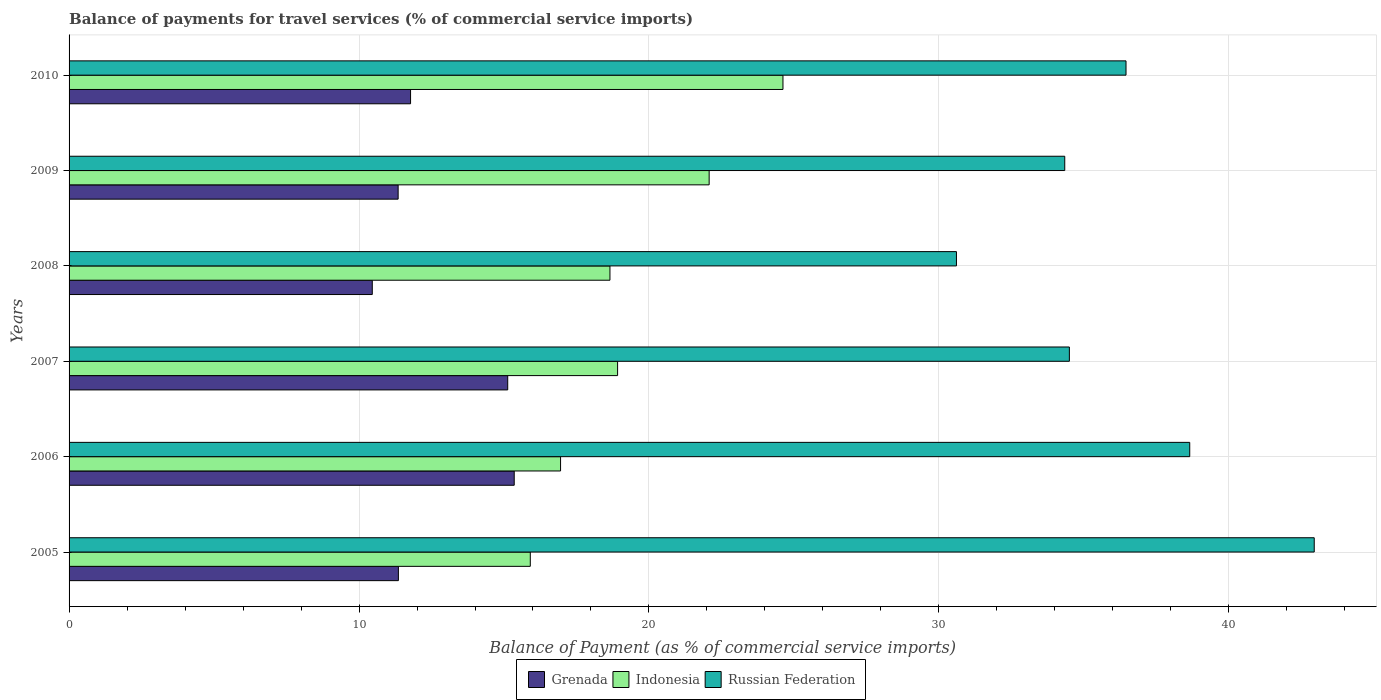How many bars are there on the 2nd tick from the top?
Provide a short and direct response. 3. How many bars are there on the 2nd tick from the bottom?
Keep it short and to the point. 3. What is the label of the 4th group of bars from the top?
Keep it short and to the point. 2007. What is the balance of payments for travel services in Indonesia in 2006?
Your answer should be compact. 16.95. Across all years, what is the maximum balance of payments for travel services in Indonesia?
Keep it short and to the point. 24.62. Across all years, what is the minimum balance of payments for travel services in Grenada?
Offer a terse response. 10.46. In which year was the balance of payments for travel services in Grenada maximum?
Provide a succinct answer. 2006. In which year was the balance of payments for travel services in Russian Federation minimum?
Your response must be concise. 2008. What is the total balance of payments for travel services in Grenada in the graph?
Provide a short and direct response. 75.42. What is the difference between the balance of payments for travel services in Indonesia in 2005 and that in 2006?
Offer a very short reply. -1.04. What is the difference between the balance of payments for travel services in Grenada in 2010 and the balance of payments for travel services in Indonesia in 2009?
Provide a short and direct response. -10.3. What is the average balance of payments for travel services in Indonesia per year?
Offer a terse response. 19.52. In the year 2008, what is the difference between the balance of payments for travel services in Indonesia and balance of payments for travel services in Russian Federation?
Provide a succinct answer. -11.95. In how many years, is the balance of payments for travel services in Russian Federation greater than 26 %?
Give a very brief answer. 6. What is the ratio of the balance of payments for travel services in Russian Federation in 2007 to that in 2010?
Keep it short and to the point. 0.95. Is the balance of payments for travel services in Indonesia in 2006 less than that in 2007?
Offer a terse response. Yes. What is the difference between the highest and the second highest balance of payments for travel services in Grenada?
Offer a very short reply. 0.22. What is the difference between the highest and the lowest balance of payments for travel services in Grenada?
Keep it short and to the point. 4.9. In how many years, is the balance of payments for travel services in Russian Federation greater than the average balance of payments for travel services in Russian Federation taken over all years?
Give a very brief answer. 3. What does the 2nd bar from the top in 2009 represents?
Give a very brief answer. Indonesia. What does the 2nd bar from the bottom in 2007 represents?
Provide a succinct answer. Indonesia. Is it the case that in every year, the sum of the balance of payments for travel services in Grenada and balance of payments for travel services in Russian Federation is greater than the balance of payments for travel services in Indonesia?
Your answer should be compact. Yes. Are all the bars in the graph horizontal?
Your answer should be compact. Yes. What is the difference between two consecutive major ticks on the X-axis?
Offer a very short reply. 10. Are the values on the major ticks of X-axis written in scientific E-notation?
Give a very brief answer. No. Where does the legend appear in the graph?
Provide a succinct answer. Bottom center. How many legend labels are there?
Provide a short and direct response. 3. How are the legend labels stacked?
Keep it short and to the point. Horizontal. What is the title of the graph?
Ensure brevity in your answer.  Balance of payments for travel services (% of commercial service imports). What is the label or title of the X-axis?
Your response must be concise. Balance of Payment (as % of commercial service imports). What is the Balance of Payment (as % of commercial service imports) of Grenada in 2005?
Make the answer very short. 11.36. What is the Balance of Payment (as % of commercial service imports) in Indonesia in 2005?
Provide a short and direct response. 15.91. What is the Balance of Payment (as % of commercial service imports) in Russian Federation in 2005?
Ensure brevity in your answer.  42.94. What is the Balance of Payment (as % of commercial service imports) of Grenada in 2006?
Provide a short and direct response. 15.35. What is the Balance of Payment (as % of commercial service imports) of Indonesia in 2006?
Your response must be concise. 16.95. What is the Balance of Payment (as % of commercial service imports) in Russian Federation in 2006?
Your response must be concise. 38.65. What is the Balance of Payment (as % of commercial service imports) in Grenada in 2007?
Give a very brief answer. 15.13. What is the Balance of Payment (as % of commercial service imports) in Indonesia in 2007?
Offer a terse response. 18.92. What is the Balance of Payment (as % of commercial service imports) of Russian Federation in 2007?
Provide a succinct answer. 34.5. What is the Balance of Payment (as % of commercial service imports) of Grenada in 2008?
Give a very brief answer. 10.46. What is the Balance of Payment (as % of commercial service imports) of Indonesia in 2008?
Offer a very short reply. 18.65. What is the Balance of Payment (as % of commercial service imports) in Russian Federation in 2008?
Your answer should be very brief. 30.6. What is the Balance of Payment (as % of commercial service imports) of Grenada in 2009?
Offer a very short reply. 11.35. What is the Balance of Payment (as % of commercial service imports) in Indonesia in 2009?
Offer a terse response. 22.08. What is the Balance of Payment (as % of commercial service imports) in Russian Federation in 2009?
Offer a very short reply. 34.34. What is the Balance of Payment (as % of commercial service imports) in Grenada in 2010?
Make the answer very short. 11.78. What is the Balance of Payment (as % of commercial service imports) in Indonesia in 2010?
Your response must be concise. 24.62. What is the Balance of Payment (as % of commercial service imports) in Russian Federation in 2010?
Keep it short and to the point. 36.45. Across all years, what is the maximum Balance of Payment (as % of commercial service imports) of Grenada?
Provide a succinct answer. 15.35. Across all years, what is the maximum Balance of Payment (as % of commercial service imports) of Indonesia?
Make the answer very short. 24.62. Across all years, what is the maximum Balance of Payment (as % of commercial service imports) in Russian Federation?
Your answer should be very brief. 42.94. Across all years, what is the minimum Balance of Payment (as % of commercial service imports) in Grenada?
Keep it short and to the point. 10.46. Across all years, what is the minimum Balance of Payment (as % of commercial service imports) of Indonesia?
Make the answer very short. 15.91. Across all years, what is the minimum Balance of Payment (as % of commercial service imports) of Russian Federation?
Keep it short and to the point. 30.6. What is the total Balance of Payment (as % of commercial service imports) in Grenada in the graph?
Your answer should be compact. 75.42. What is the total Balance of Payment (as % of commercial service imports) of Indonesia in the graph?
Give a very brief answer. 117.13. What is the total Balance of Payment (as % of commercial service imports) in Russian Federation in the graph?
Offer a very short reply. 217.49. What is the difference between the Balance of Payment (as % of commercial service imports) in Grenada in 2005 and that in 2006?
Provide a succinct answer. -3.99. What is the difference between the Balance of Payment (as % of commercial service imports) in Indonesia in 2005 and that in 2006?
Provide a short and direct response. -1.04. What is the difference between the Balance of Payment (as % of commercial service imports) of Russian Federation in 2005 and that in 2006?
Offer a very short reply. 4.29. What is the difference between the Balance of Payment (as % of commercial service imports) of Grenada in 2005 and that in 2007?
Make the answer very short. -3.77. What is the difference between the Balance of Payment (as % of commercial service imports) in Indonesia in 2005 and that in 2007?
Make the answer very short. -3.01. What is the difference between the Balance of Payment (as % of commercial service imports) of Russian Federation in 2005 and that in 2007?
Provide a succinct answer. 8.44. What is the difference between the Balance of Payment (as % of commercial service imports) in Grenada in 2005 and that in 2008?
Provide a succinct answer. 0.9. What is the difference between the Balance of Payment (as % of commercial service imports) in Indonesia in 2005 and that in 2008?
Your response must be concise. -2.75. What is the difference between the Balance of Payment (as % of commercial service imports) in Russian Federation in 2005 and that in 2008?
Your answer should be very brief. 12.34. What is the difference between the Balance of Payment (as % of commercial service imports) of Grenada in 2005 and that in 2009?
Keep it short and to the point. 0.01. What is the difference between the Balance of Payment (as % of commercial service imports) of Indonesia in 2005 and that in 2009?
Offer a terse response. -6.17. What is the difference between the Balance of Payment (as % of commercial service imports) in Russian Federation in 2005 and that in 2009?
Provide a succinct answer. 8.6. What is the difference between the Balance of Payment (as % of commercial service imports) of Grenada in 2005 and that in 2010?
Your answer should be compact. -0.42. What is the difference between the Balance of Payment (as % of commercial service imports) in Indonesia in 2005 and that in 2010?
Keep it short and to the point. -8.71. What is the difference between the Balance of Payment (as % of commercial service imports) in Russian Federation in 2005 and that in 2010?
Give a very brief answer. 6.49. What is the difference between the Balance of Payment (as % of commercial service imports) of Grenada in 2006 and that in 2007?
Provide a short and direct response. 0.22. What is the difference between the Balance of Payment (as % of commercial service imports) of Indonesia in 2006 and that in 2007?
Offer a terse response. -1.97. What is the difference between the Balance of Payment (as % of commercial service imports) of Russian Federation in 2006 and that in 2007?
Your answer should be very brief. 4.15. What is the difference between the Balance of Payment (as % of commercial service imports) of Grenada in 2006 and that in 2008?
Your answer should be very brief. 4.9. What is the difference between the Balance of Payment (as % of commercial service imports) in Indonesia in 2006 and that in 2008?
Your answer should be compact. -1.7. What is the difference between the Balance of Payment (as % of commercial service imports) of Russian Federation in 2006 and that in 2008?
Your answer should be very brief. 8.05. What is the difference between the Balance of Payment (as % of commercial service imports) of Grenada in 2006 and that in 2009?
Provide a short and direct response. 4. What is the difference between the Balance of Payment (as % of commercial service imports) of Indonesia in 2006 and that in 2009?
Ensure brevity in your answer.  -5.12. What is the difference between the Balance of Payment (as % of commercial service imports) in Russian Federation in 2006 and that in 2009?
Provide a succinct answer. 4.31. What is the difference between the Balance of Payment (as % of commercial service imports) in Grenada in 2006 and that in 2010?
Provide a succinct answer. 3.58. What is the difference between the Balance of Payment (as % of commercial service imports) of Indonesia in 2006 and that in 2010?
Provide a short and direct response. -7.67. What is the difference between the Balance of Payment (as % of commercial service imports) of Russian Federation in 2006 and that in 2010?
Provide a short and direct response. 2.2. What is the difference between the Balance of Payment (as % of commercial service imports) of Grenada in 2007 and that in 2008?
Offer a very short reply. 4.67. What is the difference between the Balance of Payment (as % of commercial service imports) in Indonesia in 2007 and that in 2008?
Offer a terse response. 0.26. What is the difference between the Balance of Payment (as % of commercial service imports) of Russian Federation in 2007 and that in 2008?
Offer a terse response. 3.89. What is the difference between the Balance of Payment (as % of commercial service imports) in Grenada in 2007 and that in 2009?
Ensure brevity in your answer.  3.78. What is the difference between the Balance of Payment (as % of commercial service imports) of Indonesia in 2007 and that in 2009?
Provide a succinct answer. -3.16. What is the difference between the Balance of Payment (as % of commercial service imports) in Russian Federation in 2007 and that in 2009?
Keep it short and to the point. 0.16. What is the difference between the Balance of Payment (as % of commercial service imports) in Grenada in 2007 and that in 2010?
Give a very brief answer. 3.35. What is the difference between the Balance of Payment (as % of commercial service imports) in Indonesia in 2007 and that in 2010?
Your answer should be very brief. -5.7. What is the difference between the Balance of Payment (as % of commercial service imports) in Russian Federation in 2007 and that in 2010?
Keep it short and to the point. -1.95. What is the difference between the Balance of Payment (as % of commercial service imports) of Grenada in 2008 and that in 2009?
Ensure brevity in your answer.  -0.89. What is the difference between the Balance of Payment (as % of commercial service imports) of Indonesia in 2008 and that in 2009?
Your answer should be compact. -3.42. What is the difference between the Balance of Payment (as % of commercial service imports) in Russian Federation in 2008 and that in 2009?
Your answer should be compact. -3.74. What is the difference between the Balance of Payment (as % of commercial service imports) of Grenada in 2008 and that in 2010?
Provide a short and direct response. -1.32. What is the difference between the Balance of Payment (as % of commercial service imports) of Indonesia in 2008 and that in 2010?
Provide a succinct answer. -5.97. What is the difference between the Balance of Payment (as % of commercial service imports) in Russian Federation in 2008 and that in 2010?
Provide a succinct answer. -5.85. What is the difference between the Balance of Payment (as % of commercial service imports) in Grenada in 2009 and that in 2010?
Give a very brief answer. -0.43. What is the difference between the Balance of Payment (as % of commercial service imports) in Indonesia in 2009 and that in 2010?
Provide a short and direct response. -2.55. What is the difference between the Balance of Payment (as % of commercial service imports) in Russian Federation in 2009 and that in 2010?
Keep it short and to the point. -2.11. What is the difference between the Balance of Payment (as % of commercial service imports) of Grenada in 2005 and the Balance of Payment (as % of commercial service imports) of Indonesia in 2006?
Your answer should be compact. -5.59. What is the difference between the Balance of Payment (as % of commercial service imports) in Grenada in 2005 and the Balance of Payment (as % of commercial service imports) in Russian Federation in 2006?
Provide a succinct answer. -27.29. What is the difference between the Balance of Payment (as % of commercial service imports) of Indonesia in 2005 and the Balance of Payment (as % of commercial service imports) of Russian Federation in 2006?
Provide a short and direct response. -22.74. What is the difference between the Balance of Payment (as % of commercial service imports) of Grenada in 2005 and the Balance of Payment (as % of commercial service imports) of Indonesia in 2007?
Offer a terse response. -7.56. What is the difference between the Balance of Payment (as % of commercial service imports) of Grenada in 2005 and the Balance of Payment (as % of commercial service imports) of Russian Federation in 2007?
Offer a very short reply. -23.14. What is the difference between the Balance of Payment (as % of commercial service imports) of Indonesia in 2005 and the Balance of Payment (as % of commercial service imports) of Russian Federation in 2007?
Provide a succinct answer. -18.59. What is the difference between the Balance of Payment (as % of commercial service imports) of Grenada in 2005 and the Balance of Payment (as % of commercial service imports) of Indonesia in 2008?
Make the answer very short. -7.3. What is the difference between the Balance of Payment (as % of commercial service imports) of Grenada in 2005 and the Balance of Payment (as % of commercial service imports) of Russian Federation in 2008?
Offer a terse response. -19.25. What is the difference between the Balance of Payment (as % of commercial service imports) of Indonesia in 2005 and the Balance of Payment (as % of commercial service imports) of Russian Federation in 2008?
Your answer should be very brief. -14.7. What is the difference between the Balance of Payment (as % of commercial service imports) of Grenada in 2005 and the Balance of Payment (as % of commercial service imports) of Indonesia in 2009?
Keep it short and to the point. -10.72. What is the difference between the Balance of Payment (as % of commercial service imports) in Grenada in 2005 and the Balance of Payment (as % of commercial service imports) in Russian Federation in 2009?
Provide a short and direct response. -22.98. What is the difference between the Balance of Payment (as % of commercial service imports) of Indonesia in 2005 and the Balance of Payment (as % of commercial service imports) of Russian Federation in 2009?
Give a very brief answer. -18.43. What is the difference between the Balance of Payment (as % of commercial service imports) of Grenada in 2005 and the Balance of Payment (as % of commercial service imports) of Indonesia in 2010?
Your response must be concise. -13.26. What is the difference between the Balance of Payment (as % of commercial service imports) in Grenada in 2005 and the Balance of Payment (as % of commercial service imports) in Russian Federation in 2010?
Your answer should be very brief. -25.09. What is the difference between the Balance of Payment (as % of commercial service imports) of Indonesia in 2005 and the Balance of Payment (as % of commercial service imports) of Russian Federation in 2010?
Your response must be concise. -20.55. What is the difference between the Balance of Payment (as % of commercial service imports) in Grenada in 2006 and the Balance of Payment (as % of commercial service imports) in Indonesia in 2007?
Your answer should be compact. -3.57. What is the difference between the Balance of Payment (as % of commercial service imports) in Grenada in 2006 and the Balance of Payment (as % of commercial service imports) in Russian Federation in 2007?
Your answer should be compact. -19.15. What is the difference between the Balance of Payment (as % of commercial service imports) in Indonesia in 2006 and the Balance of Payment (as % of commercial service imports) in Russian Federation in 2007?
Make the answer very short. -17.55. What is the difference between the Balance of Payment (as % of commercial service imports) of Grenada in 2006 and the Balance of Payment (as % of commercial service imports) of Indonesia in 2008?
Offer a terse response. -3.3. What is the difference between the Balance of Payment (as % of commercial service imports) in Grenada in 2006 and the Balance of Payment (as % of commercial service imports) in Russian Federation in 2008?
Your answer should be very brief. -15.25. What is the difference between the Balance of Payment (as % of commercial service imports) of Indonesia in 2006 and the Balance of Payment (as % of commercial service imports) of Russian Federation in 2008?
Provide a short and direct response. -13.65. What is the difference between the Balance of Payment (as % of commercial service imports) of Grenada in 2006 and the Balance of Payment (as % of commercial service imports) of Indonesia in 2009?
Offer a terse response. -6.72. What is the difference between the Balance of Payment (as % of commercial service imports) in Grenada in 2006 and the Balance of Payment (as % of commercial service imports) in Russian Federation in 2009?
Provide a short and direct response. -18.99. What is the difference between the Balance of Payment (as % of commercial service imports) in Indonesia in 2006 and the Balance of Payment (as % of commercial service imports) in Russian Federation in 2009?
Ensure brevity in your answer.  -17.39. What is the difference between the Balance of Payment (as % of commercial service imports) of Grenada in 2006 and the Balance of Payment (as % of commercial service imports) of Indonesia in 2010?
Provide a succinct answer. -9.27. What is the difference between the Balance of Payment (as % of commercial service imports) of Grenada in 2006 and the Balance of Payment (as % of commercial service imports) of Russian Federation in 2010?
Provide a succinct answer. -21.1. What is the difference between the Balance of Payment (as % of commercial service imports) of Indonesia in 2006 and the Balance of Payment (as % of commercial service imports) of Russian Federation in 2010?
Your response must be concise. -19.5. What is the difference between the Balance of Payment (as % of commercial service imports) of Grenada in 2007 and the Balance of Payment (as % of commercial service imports) of Indonesia in 2008?
Provide a succinct answer. -3.53. What is the difference between the Balance of Payment (as % of commercial service imports) of Grenada in 2007 and the Balance of Payment (as % of commercial service imports) of Russian Federation in 2008?
Make the answer very short. -15.48. What is the difference between the Balance of Payment (as % of commercial service imports) in Indonesia in 2007 and the Balance of Payment (as % of commercial service imports) in Russian Federation in 2008?
Ensure brevity in your answer.  -11.69. What is the difference between the Balance of Payment (as % of commercial service imports) of Grenada in 2007 and the Balance of Payment (as % of commercial service imports) of Indonesia in 2009?
Ensure brevity in your answer.  -6.95. What is the difference between the Balance of Payment (as % of commercial service imports) of Grenada in 2007 and the Balance of Payment (as % of commercial service imports) of Russian Federation in 2009?
Your answer should be compact. -19.21. What is the difference between the Balance of Payment (as % of commercial service imports) in Indonesia in 2007 and the Balance of Payment (as % of commercial service imports) in Russian Federation in 2009?
Give a very brief answer. -15.42. What is the difference between the Balance of Payment (as % of commercial service imports) in Grenada in 2007 and the Balance of Payment (as % of commercial service imports) in Indonesia in 2010?
Your answer should be very brief. -9.49. What is the difference between the Balance of Payment (as % of commercial service imports) in Grenada in 2007 and the Balance of Payment (as % of commercial service imports) in Russian Federation in 2010?
Make the answer very short. -21.32. What is the difference between the Balance of Payment (as % of commercial service imports) of Indonesia in 2007 and the Balance of Payment (as % of commercial service imports) of Russian Federation in 2010?
Offer a terse response. -17.54. What is the difference between the Balance of Payment (as % of commercial service imports) in Grenada in 2008 and the Balance of Payment (as % of commercial service imports) in Indonesia in 2009?
Your answer should be very brief. -11.62. What is the difference between the Balance of Payment (as % of commercial service imports) in Grenada in 2008 and the Balance of Payment (as % of commercial service imports) in Russian Federation in 2009?
Give a very brief answer. -23.88. What is the difference between the Balance of Payment (as % of commercial service imports) of Indonesia in 2008 and the Balance of Payment (as % of commercial service imports) of Russian Federation in 2009?
Make the answer very short. -15.69. What is the difference between the Balance of Payment (as % of commercial service imports) in Grenada in 2008 and the Balance of Payment (as % of commercial service imports) in Indonesia in 2010?
Ensure brevity in your answer.  -14.16. What is the difference between the Balance of Payment (as % of commercial service imports) of Grenada in 2008 and the Balance of Payment (as % of commercial service imports) of Russian Federation in 2010?
Provide a short and direct response. -26. What is the difference between the Balance of Payment (as % of commercial service imports) of Indonesia in 2008 and the Balance of Payment (as % of commercial service imports) of Russian Federation in 2010?
Give a very brief answer. -17.8. What is the difference between the Balance of Payment (as % of commercial service imports) in Grenada in 2009 and the Balance of Payment (as % of commercial service imports) in Indonesia in 2010?
Provide a succinct answer. -13.27. What is the difference between the Balance of Payment (as % of commercial service imports) of Grenada in 2009 and the Balance of Payment (as % of commercial service imports) of Russian Federation in 2010?
Ensure brevity in your answer.  -25.1. What is the difference between the Balance of Payment (as % of commercial service imports) in Indonesia in 2009 and the Balance of Payment (as % of commercial service imports) in Russian Federation in 2010?
Offer a very short reply. -14.38. What is the average Balance of Payment (as % of commercial service imports) of Grenada per year?
Keep it short and to the point. 12.57. What is the average Balance of Payment (as % of commercial service imports) in Indonesia per year?
Ensure brevity in your answer.  19.52. What is the average Balance of Payment (as % of commercial service imports) in Russian Federation per year?
Your answer should be compact. 36.25. In the year 2005, what is the difference between the Balance of Payment (as % of commercial service imports) of Grenada and Balance of Payment (as % of commercial service imports) of Indonesia?
Make the answer very short. -4.55. In the year 2005, what is the difference between the Balance of Payment (as % of commercial service imports) in Grenada and Balance of Payment (as % of commercial service imports) in Russian Federation?
Keep it short and to the point. -31.59. In the year 2005, what is the difference between the Balance of Payment (as % of commercial service imports) of Indonesia and Balance of Payment (as % of commercial service imports) of Russian Federation?
Ensure brevity in your answer.  -27.04. In the year 2006, what is the difference between the Balance of Payment (as % of commercial service imports) of Grenada and Balance of Payment (as % of commercial service imports) of Indonesia?
Make the answer very short. -1.6. In the year 2006, what is the difference between the Balance of Payment (as % of commercial service imports) of Grenada and Balance of Payment (as % of commercial service imports) of Russian Federation?
Offer a very short reply. -23.3. In the year 2006, what is the difference between the Balance of Payment (as % of commercial service imports) in Indonesia and Balance of Payment (as % of commercial service imports) in Russian Federation?
Your answer should be compact. -21.7. In the year 2007, what is the difference between the Balance of Payment (as % of commercial service imports) of Grenada and Balance of Payment (as % of commercial service imports) of Indonesia?
Provide a succinct answer. -3.79. In the year 2007, what is the difference between the Balance of Payment (as % of commercial service imports) in Grenada and Balance of Payment (as % of commercial service imports) in Russian Federation?
Provide a succinct answer. -19.37. In the year 2007, what is the difference between the Balance of Payment (as % of commercial service imports) in Indonesia and Balance of Payment (as % of commercial service imports) in Russian Federation?
Give a very brief answer. -15.58. In the year 2008, what is the difference between the Balance of Payment (as % of commercial service imports) of Grenada and Balance of Payment (as % of commercial service imports) of Indonesia?
Your answer should be compact. -8.2. In the year 2008, what is the difference between the Balance of Payment (as % of commercial service imports) in Grenada and Balance of Payment (as % of commercial service imports) in Russian Federation?
Keep it short and to the point. -20.15. In the year 2008, what is the difference between the Balance of Payment (as % of commercial service imports) in Indonesia and Balance of Payment (as % of commercial service imports) in Russian Federation?
Your answer should be compact. -11.95. In the year 2009, what is the difference between the Balance of Payment (as % of commercial service imports) in Grenada and Balance of Payment (as % of commercial service imports) in Indonesia?
Give a very brief answer. -10.73. In the year 2009, what is the difference between the Balance of Payment (as % of commercial service imports) in Grenada and Balance of Payment (as % of commercial service imports) in Russian Federation?
Keep it short and to the point. -22.99. In the year 2009, what is the difference between the Balance of Payment (as % of commercial service imports) in Indonesia and Balance of Payment (as % of commercial service imports) in Russian Federation?
Ensure brevity in your answer.  -12.26. In the year 2010, what is the difference between the Balance of Payment (as % of commercial service imports) in Grenada and Balance of Payment (as % of commercial service imports) in Indonesia?
Offer a terse response. -12.84. In the year 2010, what is the difference between the Balance of Payment (as % of commercial service imports) of Grenada and Balance of Payment (as % of commercial service imports) of Russian Federation?
Make the answer very short. -24.68. In the year 2010, what is the difference between the Balance of Payment (as % of commercial service imports) of Indonesia and Balance of Payment (as % of commercial service imports) of Russian Federation?
Make the answer very short. -11.83. What is the ratio of the Balance of Payment (as % of commercial service imports) of Grenada in 2005 to that in 2006?
Give a very brief answer. 0.74. What is the ratio of the Balance of Payment (as % of commercial service imports) of Indonesia in 2005 to that in 2006?
Make the answer very short. 0.94. What is the ratio of the Balance of Payment (as % of commercial service imports) of Grenada in 2005 to that in 2007?
Your response must be concise. 0.75. What is the ratio of the Balance of Payment (as % of commercial service imports) of Indonesia in 2005 to that in 2007?
Your answer should be compact. 0.84. What is the ratio of the Balance of Payment (as % of commercial service imports) in Russian Federation in 2005 to that in 2007?
Offer a very short reply. 1.24. What is the ratio of the Balance of Payment (as % of commercial service imports) in Grenada in 2005 to that in 2008?
Your response must be concise. 1.09. What is the ratio of the Balance of Payment (as % of commercial service imports) in Indonesia in 2005 to that in 2008?
Your answer should be compact. 0.85. What is the ratio of the Balance of Payment (as % of commercial service imports) in Russian Federation in 2005 to that in 2008?
Offer a very short reply. 1.4. What is the ratio of the Balance of Payment (as % of commercial service imports) in Indonesia in 2005 to that in 2009?
Your response must be concise. 0.72. What is the ratio of the Balance of Payment (as % of commercial service imports) in Russian Federation in 2005 to that in 2009?
Ensure brevity in your answer.  1.25. What is the ratio of the Balance of Payment (as % of commercial service imports) of Grenada in 2005 to that in 2010?
Provide a succinct answer. 0.96. What is the ratio of the Balance of Payment (as % of commercial service imports) in Indonesia in 2005 to that in 2010?
Offer a very short reply. 0.65. What is the ratio of the Balance of Payment (as % of commercial service imports) in Russian Federation in 2005 to that in 2010?
Provide a short and direct response. 1.18. What is the ratio of the Balance of Payment (as % of commercial service imports) of Grenada in 2006 to that in 2007?
Provide a succinct answer. 1.01. What is the ratio of the Balance of Payment (as % of commercial service imports) in Indonesia in 2006 to that in 2007?
Keep it short and to the point. 0.9. What is the ratio of the Balance of Payment (as % of commercial service imports) of Russian Federation in 2006 to that in 2007?
Your response must be concise. 1.12. What is the ratio of the Balance of Payment (as % of commercial service imports) of Grenada in 2006 to that in 2008?
Provide a succinct answer. 1.47. What is the ratio of the Balance of Payment (as % of commercial service imports) of Indonesia in 2006 to that in 2008?
Provide a short and direct response. 0.91. What is the ratio of the Balance of Payment (as % of commercial service imports) in Russian Federation in 2006 to that in 2008?
Offer a very short reply. 1.26. What is the ratio of the Balance of Payment (as % of commercial service imports) in Grenada in 2006 to that in 2009?
Give a very brief answer. 1.35. What is the ratio of the Balance of Payment (as % of commercial service imports) in Indonesia in 2006 to that in 2009?
Keep it short and to the point. 0.77. What is the ratio of the Balance of Payment (as % of commercial service imports) of Russian Federation in 2006 to that in 2009?
Make the answer very short. 1.13. What is the ratio of the Balance of Payment (as % of commercial service imports) in Grenada in 2006 to that in 2010?
Offer a terse response. 1.3. What is the ratio of the Balance of Payment (as % of commercial service imports) of Indonesia in 2006 to that in 2010?
Give a very brief answer. 0.69. What is the ratio of the Balance of Payment (as % of commercial service imports) in Russian Federation in 2006 to that in 2010?
Your response must be concise. 1.06. What is the ratio of the Balance of Payment (as % of commercial service imports) of Grenada in 2007 to that in 2008?
Provide a succinct answer. 1.45. What is the ratio of the Balance of Payment (as % of commercial service imports) of Indonesia in 2007 to that in 2008?
Offer a very short reply. 1.01. What is the ratio of the Balance of Payment (as % of commercial service imports) in Russian Federation in 2007 to that in 2008?
Make the answer very short. 1.13. What is the ratio of the Balance of Payment (as % of commercial service imports) in Grenada in 2007 to that in 2009?
Give a very brief answer. 1.33. What is the ratio of the Balance of Payment (as % of commercial service imports) in Indonesia in 2007 to that in 2009?
Your answer should be compact. 0.86. What is the ratio of the Balance of Payment (as % of commercial service imports) of Grenada in 2007 to that in 2010?
Provide a short and direct response. 1.28. What is the ratio of the Balance of Payment (as % of commercial service imports) in Indonesia in 2007 to that in 2010?
Make the answer very short. 0.77. What is the ratio of the Balance of Payment (as % of commercial service imports) in Russian Federation in 2007 to that in 2010?
Your answer should be very brief. 0.95. What is the ratio of the Balance of Payment (as % of commercial service imports) of Grenada in 2008 to that in 2009?
Offer a terse response. 0.92. What is the ratio of the Balance of Payment (as % of commercial service imports) in Indonesia in 2008 to that in 2009?
Your answer should be compact. 0.84. What is the ratio of the Balance of Payment (as % of commercial service imports) in Russian Federation in 2008 to that in 2009?
Your answer should be compact. 0.89. What is the ratio of the Balance of Payment (as % of commercial service imports) in Grenada in 2008 to that in 2010?
Make the answer very short. 0.89. What is the ratio of the Balance of Payment (as % of commercial service imports) of Indonesia in 2008 to that in 2010?
Give a very brief answer. 0.76. What is the ratio of the Balance of Payment (as % of commercial service imports) in Russian Federation in 2008 to that in 2010?
Your answer should be compact. 0.84. What is the ratio of the Balance of Payment (as % of commercial service imports) of Grenada in 2009 to that in 2010?
Ensure brevity in your answer.  0.96. What is the ratio of the Balance of Payment (as % of commercial service imports) of Indonesia in 2009 to that in 2010?
Provide a succinct answer. 0.9. What is the ratio of the Balance of Payment (as % of commercial service imports) in Russian Federation in 2009 to that in 2010?
Your answer should be very brief. 0.94. What is the difference between the highest and the second highest Balance of Payment (as % of commercial service imports) in Grenada?
Make the answer very short. 0.22. What is the difference between the highest and the second highest Balance of Payment (as % of commercial service imports) of Indonesia?
Ensure brevity in your answer.  2.55. What is the difference between the highest and the second highest Balance of Payment (as % of commercial service imports) in Russian Federation?
Your response must be concise. 4.29. What is the difference between the highest and the lowest Balance of Payment (as % of commercial service imports) of Grenada?
Provide a succinct answer. 4.9. What is the difference between the highest and the lowest Balance of Payment (as % of commercial service imports) of Indonesia?
Provide a succinct answer. 8.71. What is the difference between the highest and the lowest Balance of Payment (as % of commercial service imports) of Russian Federation?
Provide a short and direct response. 12.34. 